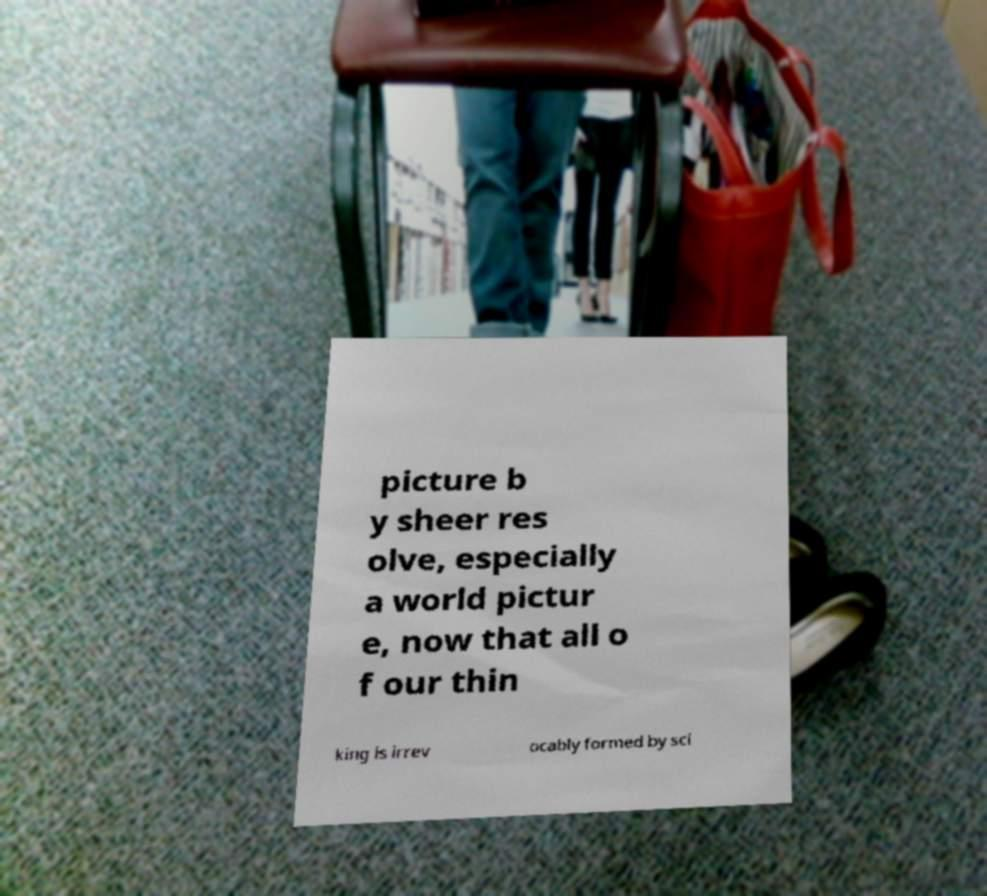Could you assist in decoding the text presented in this image and type it out clearly? picture b y sheer res olve, especially a world pictur e, now that all o f our thin king is irrev ocably formed by sci 